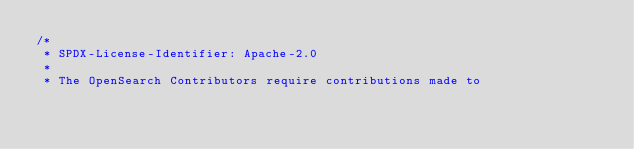<code> <loc_0><loc_0><loc_500><loc_500><_Java_>/*
 * SPDX-License-Identifier: Apache-2.0
 *
 * The OpenSearch Contributors require contributions made to</code> 